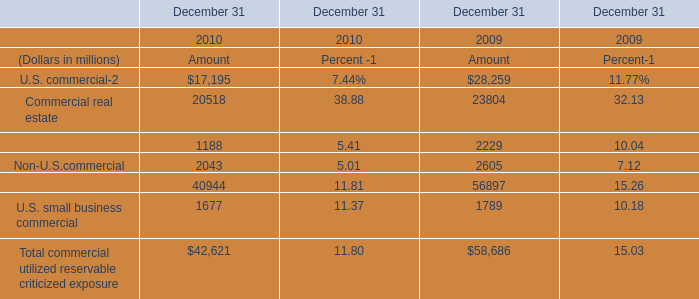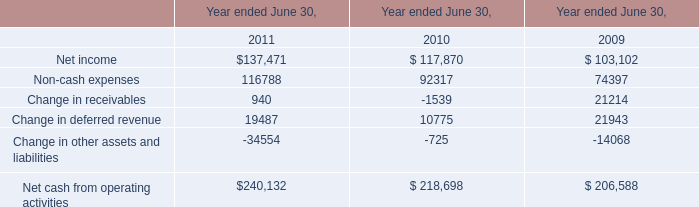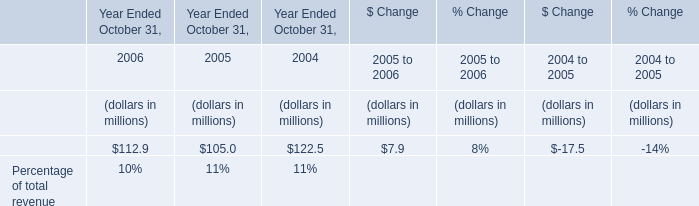What is the average amount of Net income of Year ended June 30, 2011, and U.S. commercial of December 31 2010 Amount ? 
Computations: ((137471.0 + 17195.0) / 2)
Answer: 77333.0. 